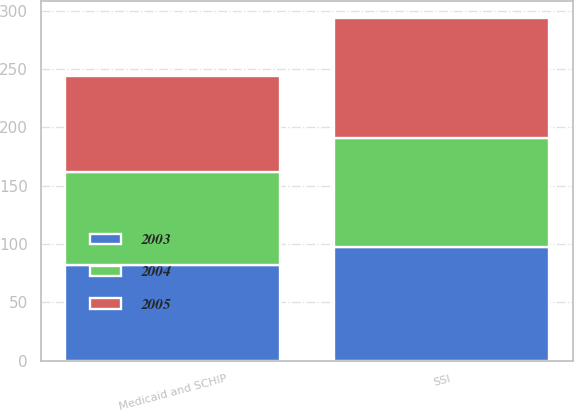Convert chart. <chart><loc_0><loc_0><loc_500><loc_500><stacked_bar_chart><ecel><fcel>Medicaid and SCHIP<fcel>SSI<nl><fcel>2003<fcel>81.7<fcel>97.5<nl><fcel>2004<fcel>80.4<fcel>93.8<nl><fcel>2005<fcel>81.7<fcel>102.5<nl></chart> 